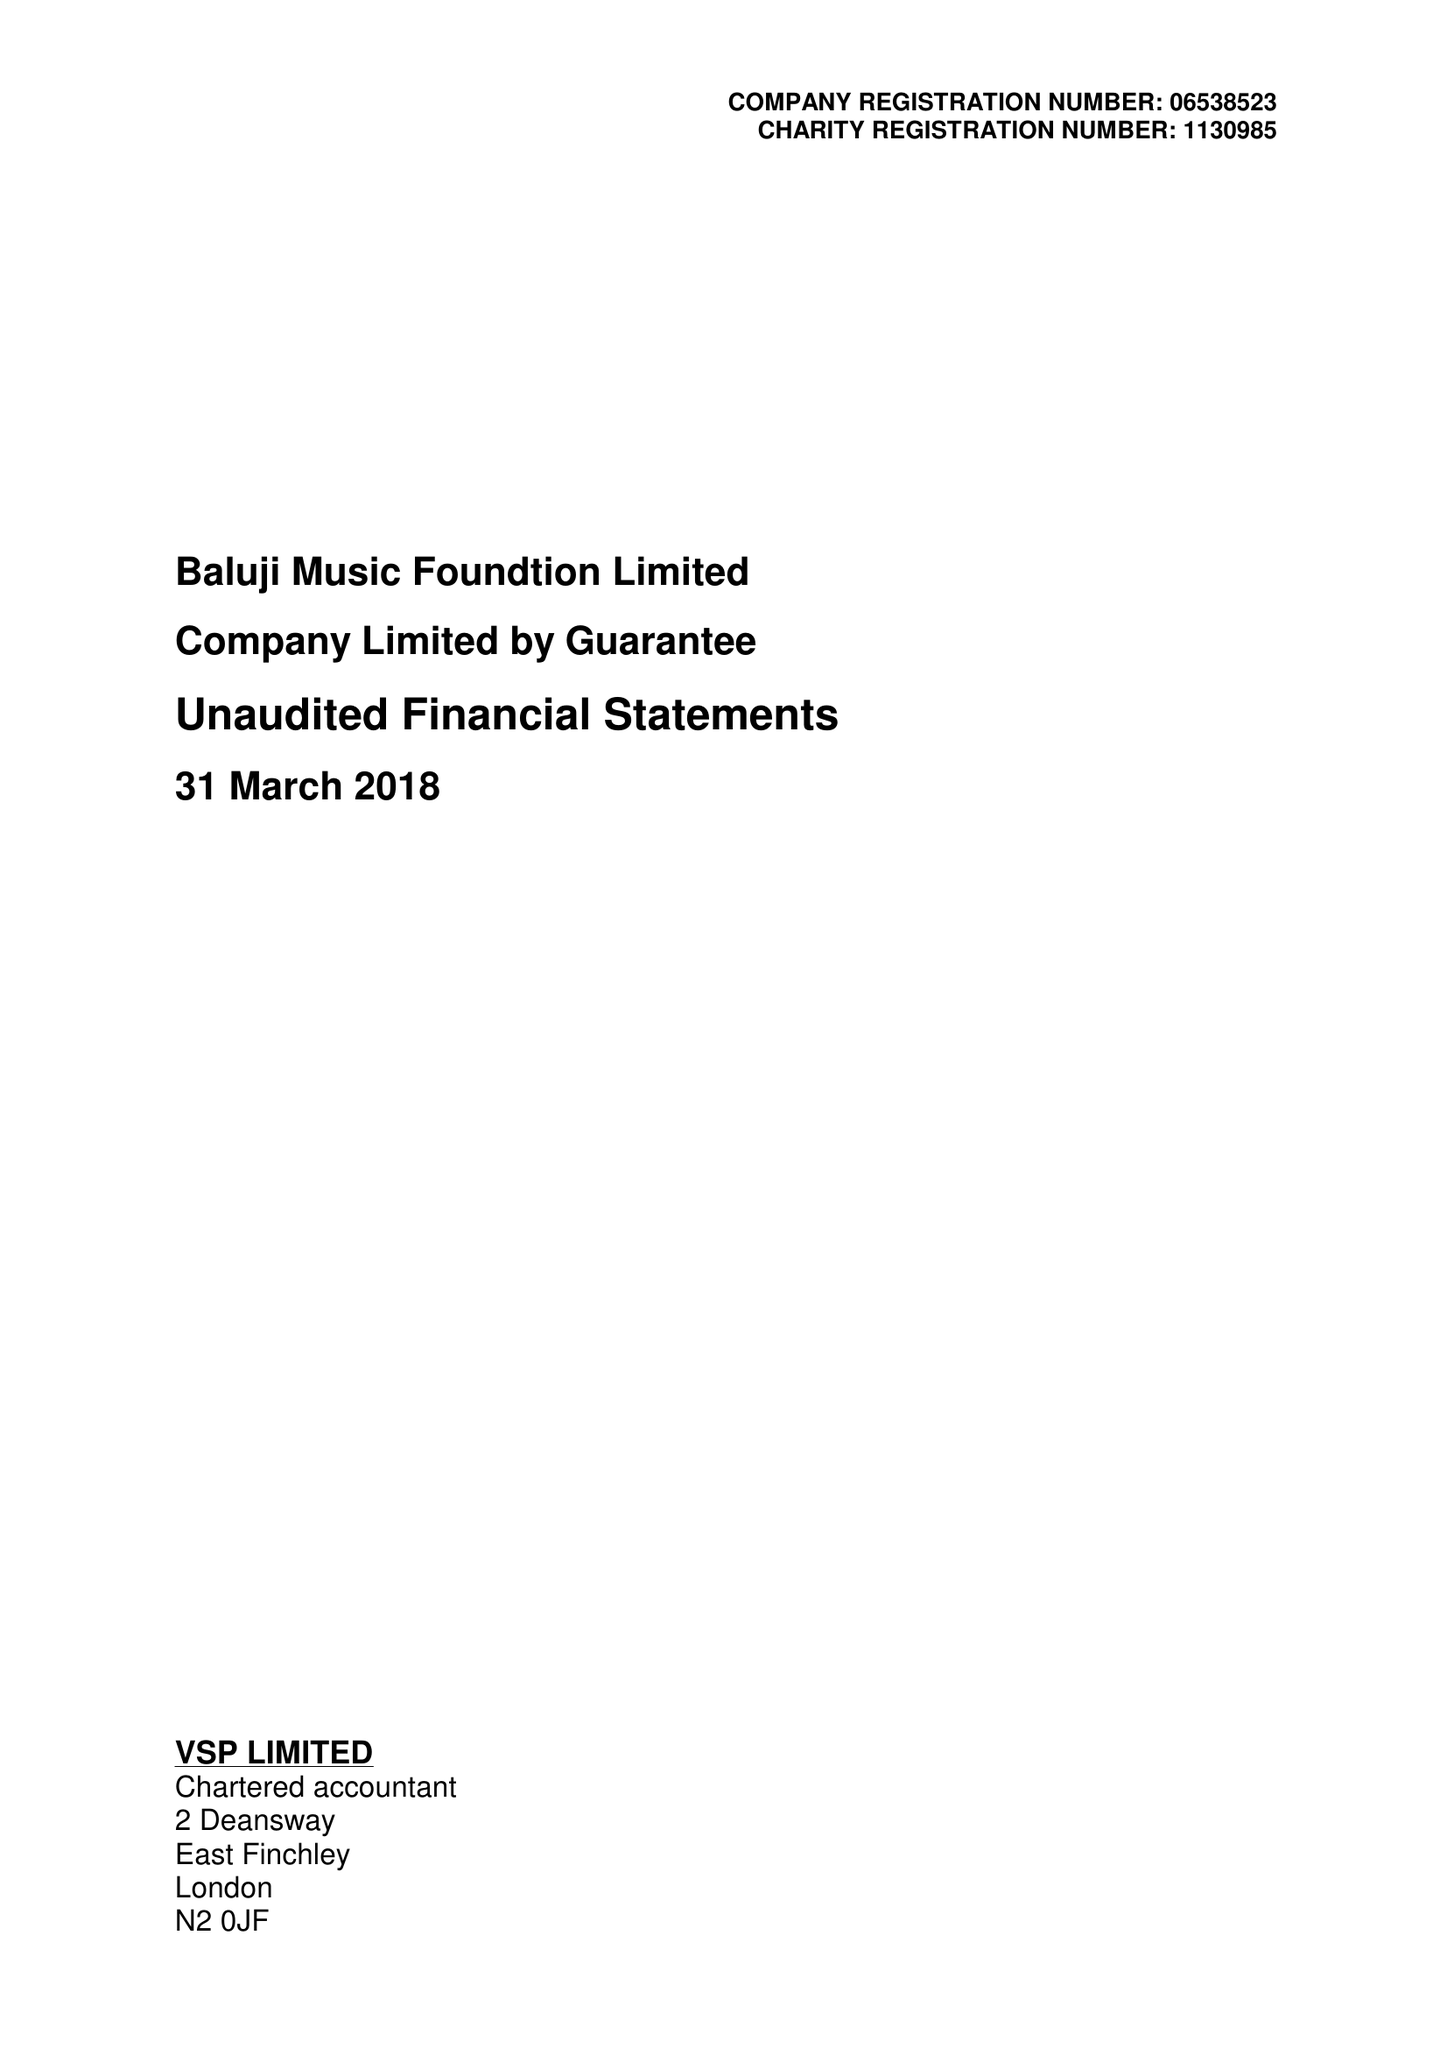What is the value for the address__post_town?
Answer the question using a single word or phrase. LONDON 